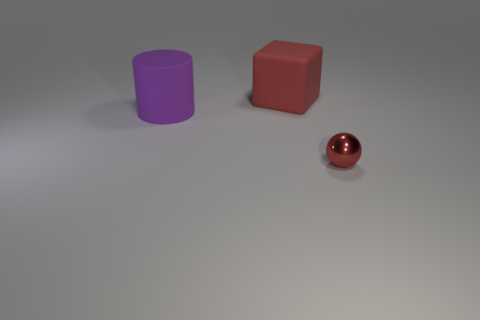Is the tiny shiny thing the same color as the large rubber block?
Provide a short and direct response. Yes. How many other things are there of the same material as the large cylinder?
Keep it short and to the point. 1. Is the number of cylinders left of the purple matte thing the same as the number of large purple objects?
Offer a very short reply. No. Do the red thing behind the purple cylinder and the small metal object have the same size?
Offer a very short reply. No. There is a small red thing; how many tiny objects are to the right of it?
Ensure brevity in your answer.  0. There is a object that is both in front of the red cube and left of the metallic sphere; what material is it made of?
Offer a terse response. Rubber. How many small objects are matte things or metal things?
Offer a very short reply. 1. The red matte block is what size?
Make the answer very short. Large. There is a small red thing; what shape is it?
Your answer should be compact. Sphere. Is there any other thing that has the same shape as the big red thing?
Keep it short and to the point. No. 